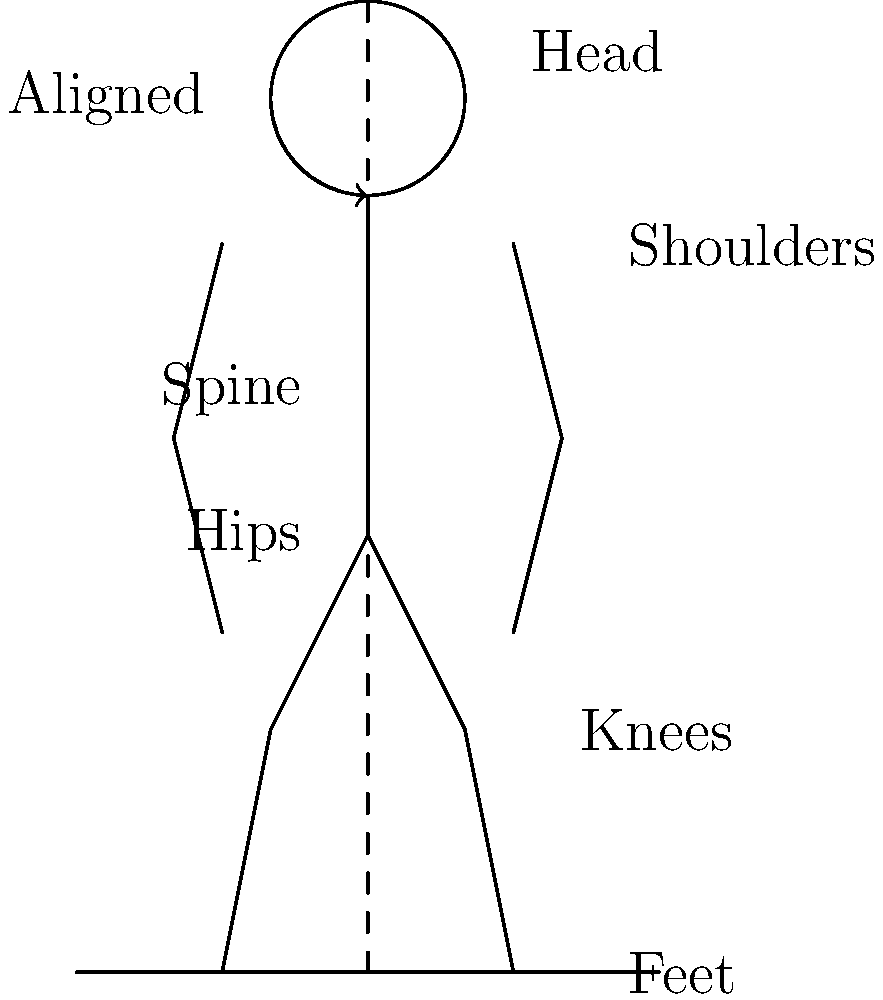In proper singing posture, which body parts should be vertically aligned to create a straight line from the top of the head to the feet, as shown in the stick figure diagram? To understand proper singing posture, let's break down the alignment of the body:

1. Head position: The head should be balanced on top of the spine, neither tilted forward nor backward. This allows for optimal breathing and vocal cord function.

2. Shoulders: They should be relaxed and level, not hunched or raised. This reduces tension in the neck and upper body.

3. Spine: The spine should maintain its natural curves but be elongated, creating a sense of "standing tall."

4. Hips: The hips should be level and in line with the shoulders, creating a neutral pelvis position.

5. Knees: They should be relaxed, not locked or bent excessively.

6. Feet: The feet should be shoulder-width apart, providing a stable base.

The key to proper singing posture is the vertical alignment of these body parts. When viewed from the side, as in our stick figure diagram, you should be able to draw an imaginary straight line that passes through:

- The top of the head
- The ear
- The shoulder joint
- The hip joint
- The knee
- The ankle

This alignment allows for optimal breath support, reduces unnecessary tension, and promotes efficient vocal production. It's particularly important for a singer-songwriter who may be performing for extended periods, as it helps prevent fatigue and strain on the voice and body.
Answer: Head, ear, shoulder, hip, knee, and ankle 